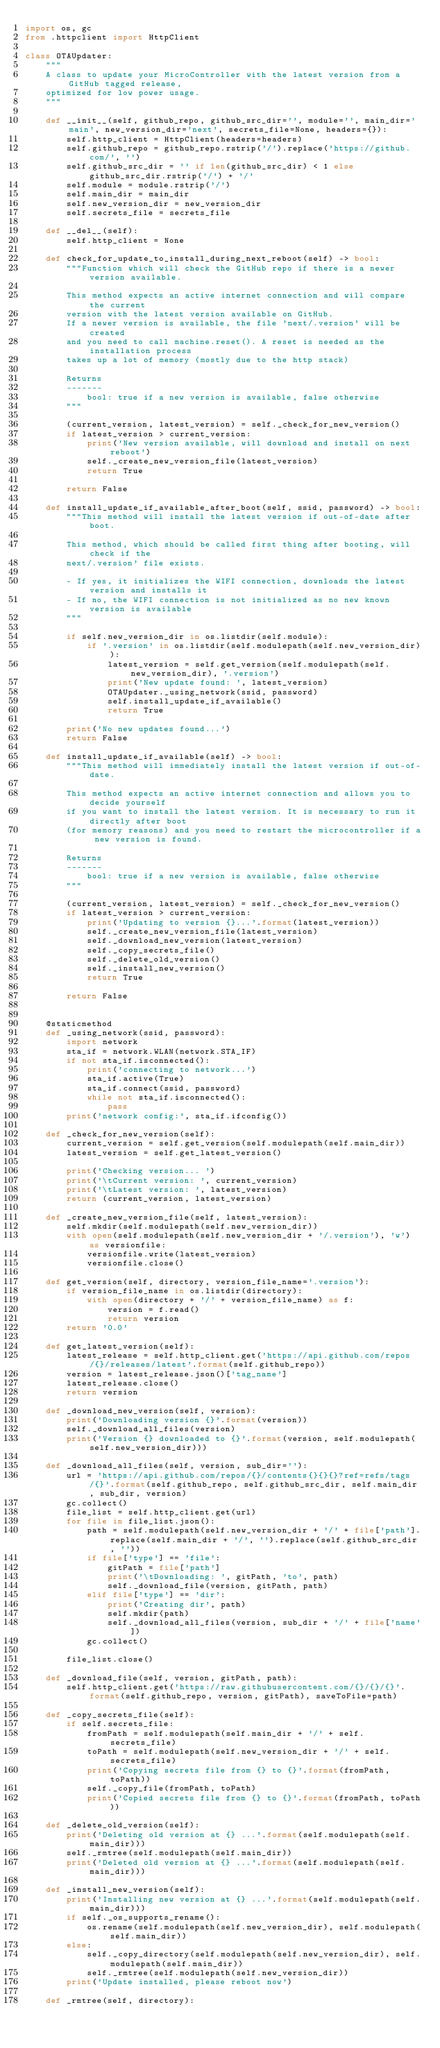<code> <loc_0><loc_0><loc_500><loc_500><_Python_>import os, gc
from .httpclient import HttpClient

class OTAUpdater:
    """
    A class to update your MicroController with the latest version from a GitHub tagged release,
    optimized for low power usage.
    """

    def __init__(self, github_repo, github_src_dir='', module='', main_dir='main', new_version_dir='next', secrets_file=None, headers={}):
        self.http_client = HttpClient(headers=headers)
        self.github_repo = github_repo.rstrip('/').replace('https://github.com/', '')
        self.github_src_dir = '' if len(github_src_dir) < 1 else github_src_dir.rstrip('/') + '/'
        self.module = module.rstrip('/')
        self.main_dir = main_dir
        self.new_version_dir = new_version_dir
        self.secrets_file = secrets_file

    def __del__(self):
        self.http_client = None

    def check_for_update_to_install_during_next_reboot(self) -> bool:
        """Function which will check the GitHub repo if there is a newer version available.
        
        This method expects an active internet connection and will compare the current 
        version with the latest version available on GitHub.
        If a newer version is available, the file 'next/.version' will be created 
        and you need to call machine.reset(). A reset is needed as the installation process 
        takes up a lot of memory (mostly due to the http stack)

        Returns
        -------
            bool: true if a new version is available, false otherwise
        """

        (current_version, latest_version) = self._check_for_new_version()
        if latest_version > current_version:
            print('New version available, will download and install on next reboot')
            self._create_new_version_file(latest_version)
            return True

        return False

    def install_update_if_available_after_boot(self, ssid, password) -> bool:
        """This method will install the latest version if out-of-date after boot.
        
        This method, which should be called first thing after booting, will check if the 
        next/.version' file exists. 

        - If yes, it initializes the WIFI connection, downloads the latest version and installs it
        - If no, the WIFI connection is not initialized as no new known version is available
        """

        if self.new_version_dir in os.listdir(self.module):
            if '.version' in os.listdir(self.modulepath(self.new_version_dir)):
                latest_version = self.get_version(self.modulepath(self.new_version_dir), '.version')
                print('New update found: ', latest_version)
                OTAUpdater._using_network(ssid, password)
                self.install_update_if_available()
                return True
            
        print('No new updates found...')
        return False

    def install_update_if_available(self) -> bool:
        """This method will immediately install the latest version if out-of-date.
        
        This method expects an active internet connection and allows you to decide yourself
        if you want to install the latest version. It is necessary to run it directly after boot 
        (for memory reasons) and you need to restart the microcontroller if a new version is found.

        Returns
        -------
            bool: true if a new version is available, false otherwise
        """

        (current_version, latest_version) = self._check_for_new_version()
        if latest_version > current_version:
            print('Updating to version {}...'.format(latest_version))
            self._create_new_version_file(latest_version)
            self._download_new_version(latest_version)
            self._copy_secrets_file()
            self._delete_old_version()
            self._install_new_version()
            return True
        
        return False


    @staticmethod
    def _using_network(ssid, password):
        import network
        sta_if = network.WLAN(network.STA_IF)
        if not sta_if.isconnected():
            print('connecting to network...')
            sta_if.active(True)
            sta_if.connect(ssid, password)
            while not sta_if.isconnected():
                pass
        print('network config:', sta_if.ifconfig())

    def _check_for_new_version(self):
        current_version = self.get_version(self.modulepath(self.main_dir))
        latest_version = self.get_latest_version()

        print('Checking version... ')
        print('\tCurrent version: ', current_version)
        print('\tLatest version: ', latest_version)
        return (current_version, latest_version)

    def _create_new_version_file(self, latest_version):
        self.mkdir(self.modulepath(self.new_version_dir))
        with open(self.modulepath(self.new_version_dir + '/.version'), 'w') as versionfile:
            versionfile.write(latest_version)
            versionfile.close()

    def get_version(self, directory, version_file_name='.version'):
        if version_file_name in os.listdir(directory):
            with open(directory + '/' + version_file_name) as f:
                version = f.read()
                return version
        return '0.0'

    def get_latest_version(self):
        latest_release = self.http_client.get('https://api.github.com/repos/{}/releases/latest'.format(self.github_repo))        
        version = latest_release.json()['tag_name']
        latest_release.close()
        return version

    def _download_new_version(self, version):
        print('Downloading version {}'.format(version))
        self._download_all_files(version)
        print('Version {} downloaded to {}'.format(version, self.modulepath(self.new_version_dir)))

    def _download_all_files(self, version, sub_dir=''):
        url = 'https://api.github.com/repos/{}/contents{}{}{}?ref=refs/tags/{}'.format(self.github_repo, self.github_src_dir, self.main_dir, sub_dir, version)
        gc.collect() 
        file_list = self.http_client.get(url)
        for file in file_list.json():
            path = self.modulepath(self.new_version_dir + '/' + file['path'].replace(self.main_dir + '/', '').replace(self.github_src_dir, ''))
            if file['type'] == 'file':
                gitPath = file['path']
                print('\tDownloading: ', gitPath, 'to', path)
                self._download_file(version, gitPath, path)
            elif file['type'] == 'dir':
                print('Creating dir', path)
                self.mkdir(path)
                self._download_all_files(version, sub_dir + '/' + file['name'])
            gc.collect()

        file_list.close()

    def _download_file(self, version, gitPath, path):
        self.http_client.get('https://raw.githubusercontent.com/{}/{}/{}'.format(self.github_repo, version, gitPath), saveToFile=path)

    def _copy_secrets_file(self):
        if self.secrets_file:
            fromPath = self.modulepath(self.main_dir + '/' + self.secrets_file)
            toPath = self.modulepath(self.new_version_dir + '/' + self.secrets_file)
            print('Copying secrets file from {} to {}'.format(fromPath, toPath))
            self._copy_file(fromPath, toPath)
            print('Copied secrets file from {} to {}'.format(fromPath, toPath))

    def _delete_old_version(self):
        print('Deleting old version at {} ...'.format(self.modulepath(self.main_dir)))
        self._rmtree(self.modulepath(self.main_dir))
        print('Deleted old version at {} ...'.format(self.modulepath(self.main_dir)))

    def _install_new_version(self):
        print('Installing new version at {} ...'.format(self.modulepath(self.main_dir)))
        if self._os_supports_rename():
            os.rename(self.modulepath(self.new_version_dir), self.modulepath(self.main_dir))
        else:
            self._copy_directory(self.modulepath(self.new_version_dir), self.modulepath(self.main_dir))
            self._rmtree(self.modulepath(self.new_version_dir))
        print('Update installed, please reboot now')

    def _rmtree(self, directory):</code> 